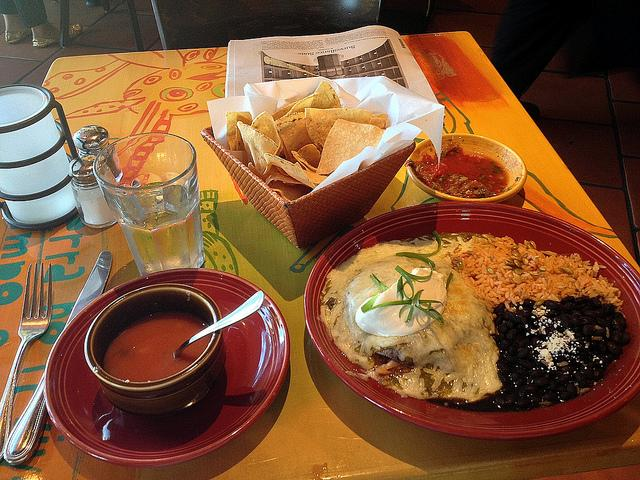How many people will dine at this table? Please explain your reasoning. one. There is only food for one person. 